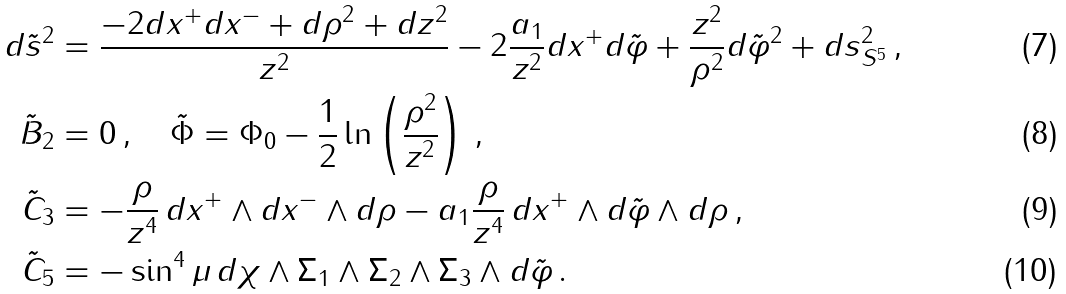<formula> <loc_0><loc_0><loc_500><loc_500>d \tilde { s } ^ { 2 } & = \frac { - 2 d x ^ { + } d x ^ { - } + d \rho ^ { 2 } + d z ^ { 2 } } { z ^ { 2 } } - 2 \frac { a _ { 1 } } { z ^ { 2 } } d x ^ { + } d \tilde { \varphi } + \frac { z ^ { 2 } } { \rho ^ { 2 } } d \tilde { \varphi } ^ { 2 } + d s ^ { 2 } _ { S ^ { 5 } } \, , \\ \tilde { B } _ { 2 } & = 0 \, , \quad \tilde { \Phi } = \Phi _ { 0 } - \frac { 1 } { 2 } \ln \left ( \frac { \rho ^ { 2 } } { z ^ { 2 } } \right ) \, , \\ \tilde { C } _ { 3 } & = - \frac { \rho } { z ^ { 4 } } \, d x ^ { + } \wedge d x ^ { - } \wedge d \rho - a _ { 1 } \frac { \rho } { z ^ { 4 } } \, d x ^ { + } \wedge d \tilde { \varphi } \wedge d \rho \, , \\ \tilde { C } _ { 5 } & = - \sin ^ { 4 } \mu \, d \chi \wedge \Sigma _ { 1 } \wedge \Sigma _ { 2 } \wedge \Sigma _ { 3 } \wedge d \tilde { \varphi } \, .</formula> 